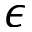<formula> <loc_0><loc_0><loc_500><loc_500>\epsilon</formula> 